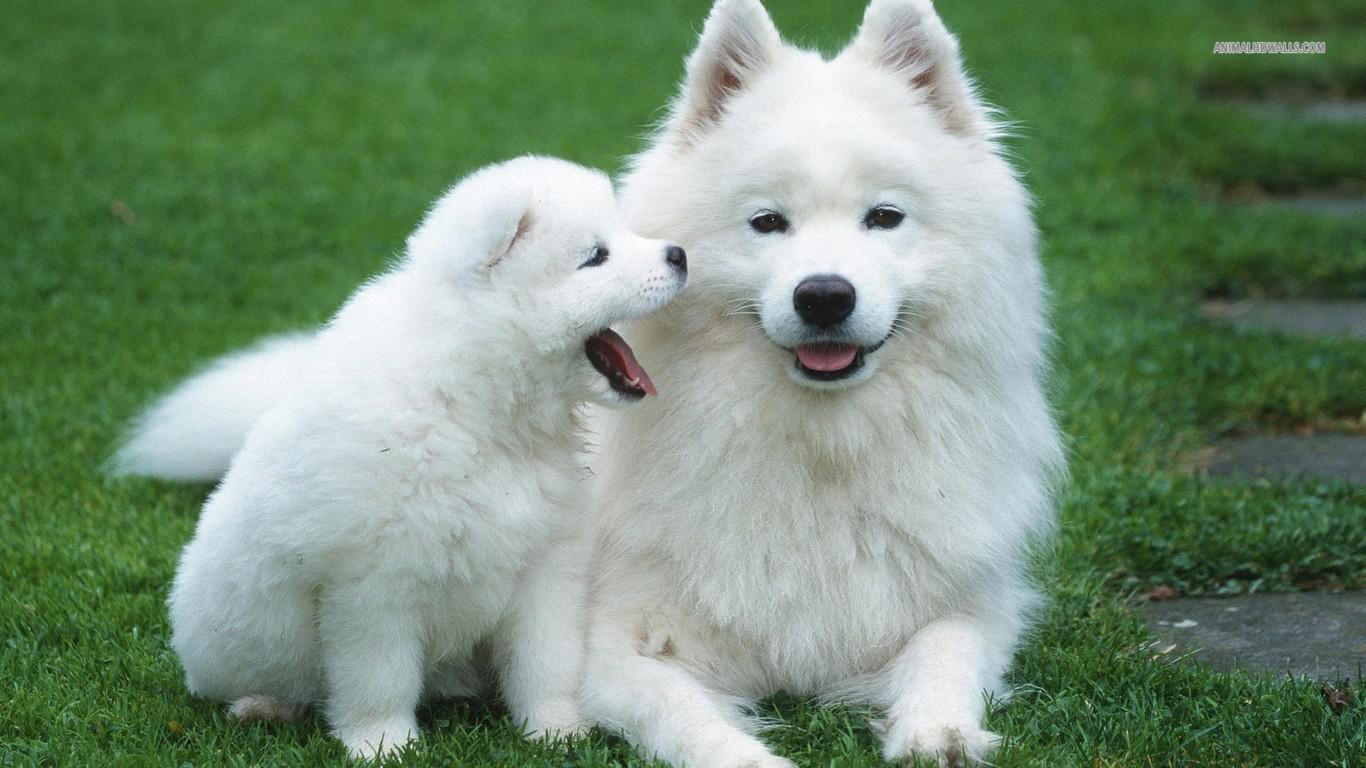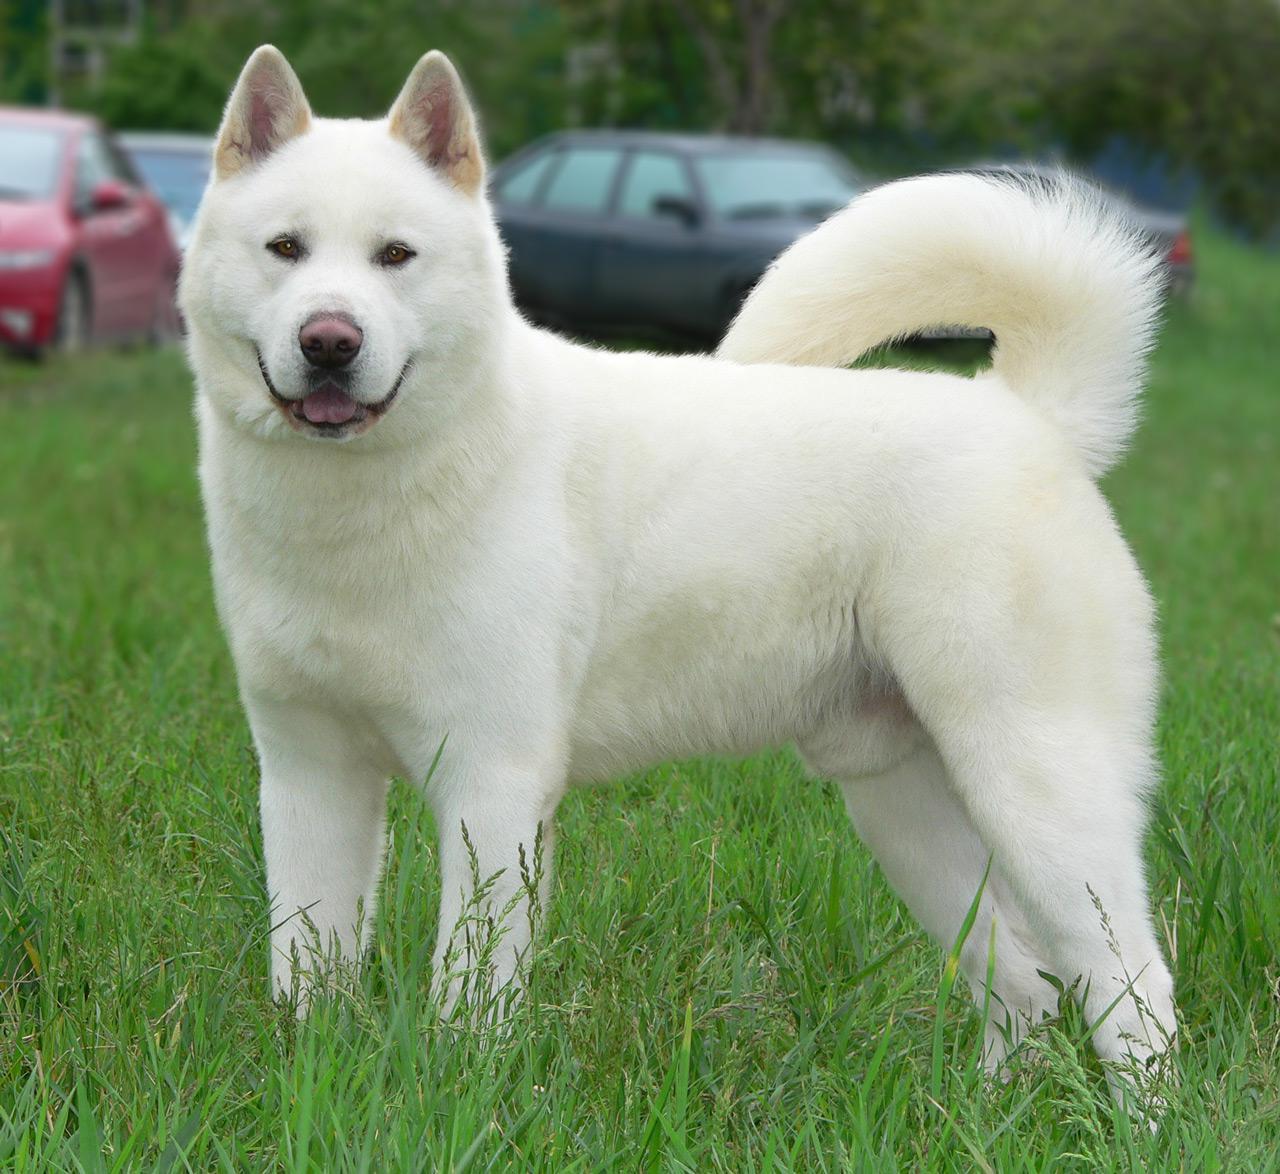The first image is the image on the left, the second image is the image on the right. Assess this claim about the two images: "An adult dog is lying down next to a puppy.". Correct or not? Answer yes or no. Yes. 